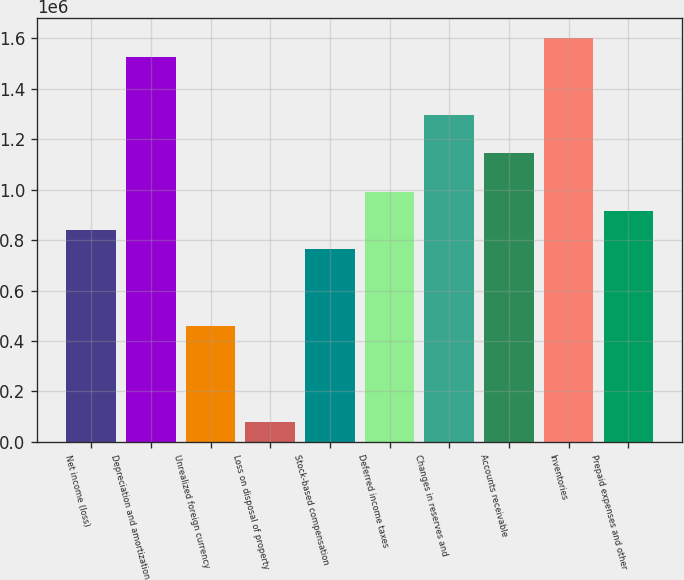Convert chart. <chart><loc_0><loc_0><loc_500><loc_500><bar_chart><fcel>Net income (loss)<fcel>Depreciation and amortization<fcel>Unrealized foreign currency<fcel>Loss on disposal of property<fcel>Stock-based compensation<fcel>Deferred income taxes<fcel>Changes in reserves and<fcel>Accounts receivable<fcel>Inventories<fcel>Prepaid expenses and other<nl><fcel>839135<fcel>1.52435e+06<fcel>458459<fcel>77783.2<fcel>763000<fcel>991406<fcel>1.29595e+06<fcel>1.14368e+06<fcel>1.60049e+06<fcel>915270<nl></chart> 